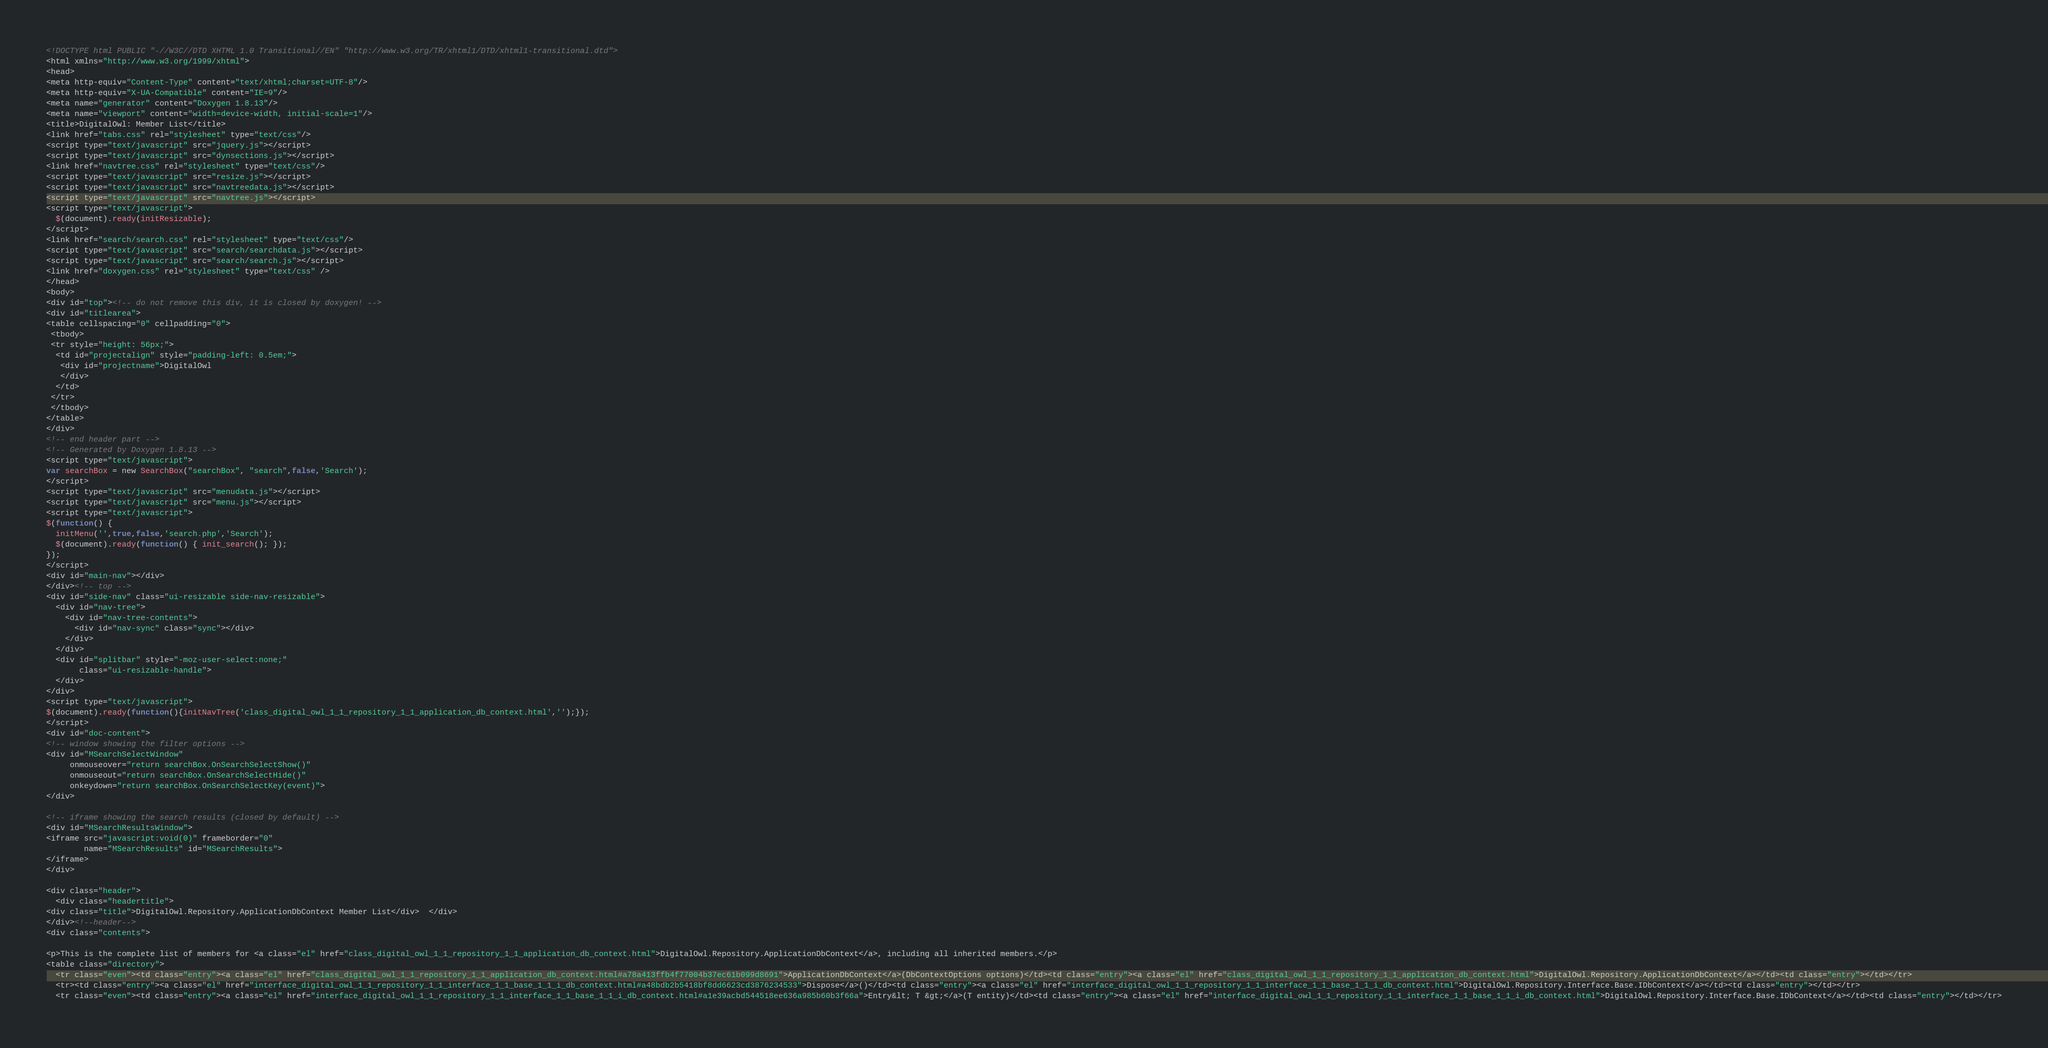<code> <loc_0><loc_0><loc_500><loc_500><_HTML_><!DOCTYPE html PUBLIC "-//W3C//DTD XHTML 1.0 Transitional//EN" "http://www.w3.org/TR/xhtml1/DTD/xhtml1-transitional.dtd">
<html xmlns="http://www.w3.org/1999/xhtml">
<head>
<meta http-equiv="Content-Type" content="text/xhtml;charset=UTF-8"/>
<meta http-equiv="X-UA-Compatible" content="IE=9"/>
<meta name="generator" content="Doxygen 1.8.13"/>
<meta name="viewport" content="width=device-width, initial-scale=1"/>
<title>DigitalOwl: Member List</title>
<link href="tabs.css" rel="stylesheet" type="text/css"/>
<script type="text/javascript" src="jquery.js"></script>
<script type="text/javascript" src="dynsections.js"></script>
<link href="navtree.css" rel="stylesheet" type="text/css"/>
<script type="text/javascript" src="resize.js"></script>
<script type="text/javascript" src="navtreedata.js"></script>
<script type="text/javascript" src="navtree.js"></script>
<script type="text/javascript">
  $(document).ready(initResizable);
</script>
<link href="search/search.css" rel="stylesheet" type="text/css"/>
<script type="text/javascript" src="search/searchdata.js"></script>
<script type="text/javascript" src="search/search.js"></script>
<link href="doxygen.css" rel="stylesheet" type="text/css" />
</head>
<body>
<div id="top"><!-- do not remove this div, it is closed by doxygen! -->
<div id="titlearea">
<table cellspacing="0" cellpadding="0">
 <tbody>
 <tr style="height: 56px;">
  <td id="projectalign" style="padding-left: 0.5em;">
   <div id="projectname">DigitalOwl
   </div>
  </td>
 </tr>
 </tbody>
</table>
</div>
<!-- end header part -->
<!-- Generated by Doxygen 1.8.13 -->
<script type="text/javascript">
var searchBox = new SearchBox("searchBox", "search",false,'Search');
</script>
<script type="text/javascript" src="menudata.js"></script>
<script type="text/javascript" src="menu.js"></script>
<script type="text/javascript">
$(function() {
  initMenu('',true,false,'search.php','Search');
  $(document).ready(function() { init_search(); });
});
</script>
<div id="main-nav"></div>
</div><!-- top -->
<div id="side-nav" class="ui-resizable side-nav-resizable">
  <div id="nav-tree">
    <div id="nav-tree-contents">
      <div id="nav-sync" class="sync"></div>
    </div>
  </div>
  <div id="splitbar" style="-moz-user-select:none;" 
       class="ui-resizable-handle">
  </div>
</div>
<script type="text/javascript">
$(document).ready(function(){initNavTree('class_digital_owl_1_1_repository_1_1_application_db_context.html','');});
</script>
<div id="doc-content">
<!-- window showing the filter options -->
<div id="MSearchSelectWindow"
     onmouseover="return searchBox.OnSearchSelectShow()"
     onmouseout="return searchBox.OnSearchSelectHide()"
     onkeydown="return searchBox.OnSearchSelectKey(event)">
</div>

<!-- iframe showing the search results (closed by default) -->
<div id="MSearchResultsWindow">
<iframe src="javascript:void(0)" frameborder="0" 
        name="MSearchResults" id="MSearchResults">
</iframe>
</div>

<div class="header">
  <div class="headertitle">
<div class="title">DigitalOwl.Repository.ApplicationDbContext Member List</div>  </div>
</div><!--header-->
<div class="contents">

<p>This is the complete list of members for <a class="el" href="class_digital_owl_1_1_repository_1_1_application_db_context.html">DigitalOwl.Repository.ApplicationDbContext</a>, including all inherited members.</p>
<table class="directory">
  <tr class="even"><td class="entry"><a class="el" href="class_digital_owl_1_1_repository_1_1_application_db_context.html#a78a413ffb4f77004b37ec61b099d8691">ApplicationDbContext</a>(DbContextOptions options)</td><td class="entry"><a class="el" href="class_digital_owl_1_1_repository_1_1_application_db_context.html">DigitalOwl.Repository.ApplicationDbContext</a></td><td class="entry"></td></tr>
  <tr><td class="entry"><a class="el" href="interface_digital_owl_1_1_repository_1_1_interface_1_1_base_1_1_i_db_context.html#a48bdb2b5418bf8dd6623cd3876234533">Dispose</a>()</td><td class="entry"><a class="el" href="interface_digital_owl_1_1_repository_1_1_interface_1_1_base_1_1_i_db_context.html">DigitalOwl.Repository.Interface.Base.IDbContext</a></td><td class="entry"></td></tr>
  <tr class="even"><td class="entry"><a class="el" href="interface_digital_owl_1_1_repository_1_1_interface_1_1_base_1_1_i_db_context.html#a1e39acbd544518ee636a985b60b3f66a">Entry&lt; T &gt;</a>(T entity)</td><td class="entry"><a class="el" href="interface_digital_owl_1_1_repository_1_1_interface_1_1_base_1_1_i_db_context.html">DigitalOwl.Repository.Interface.Base.IDbContext</a></td><td class="entry"></td></tr></code> 